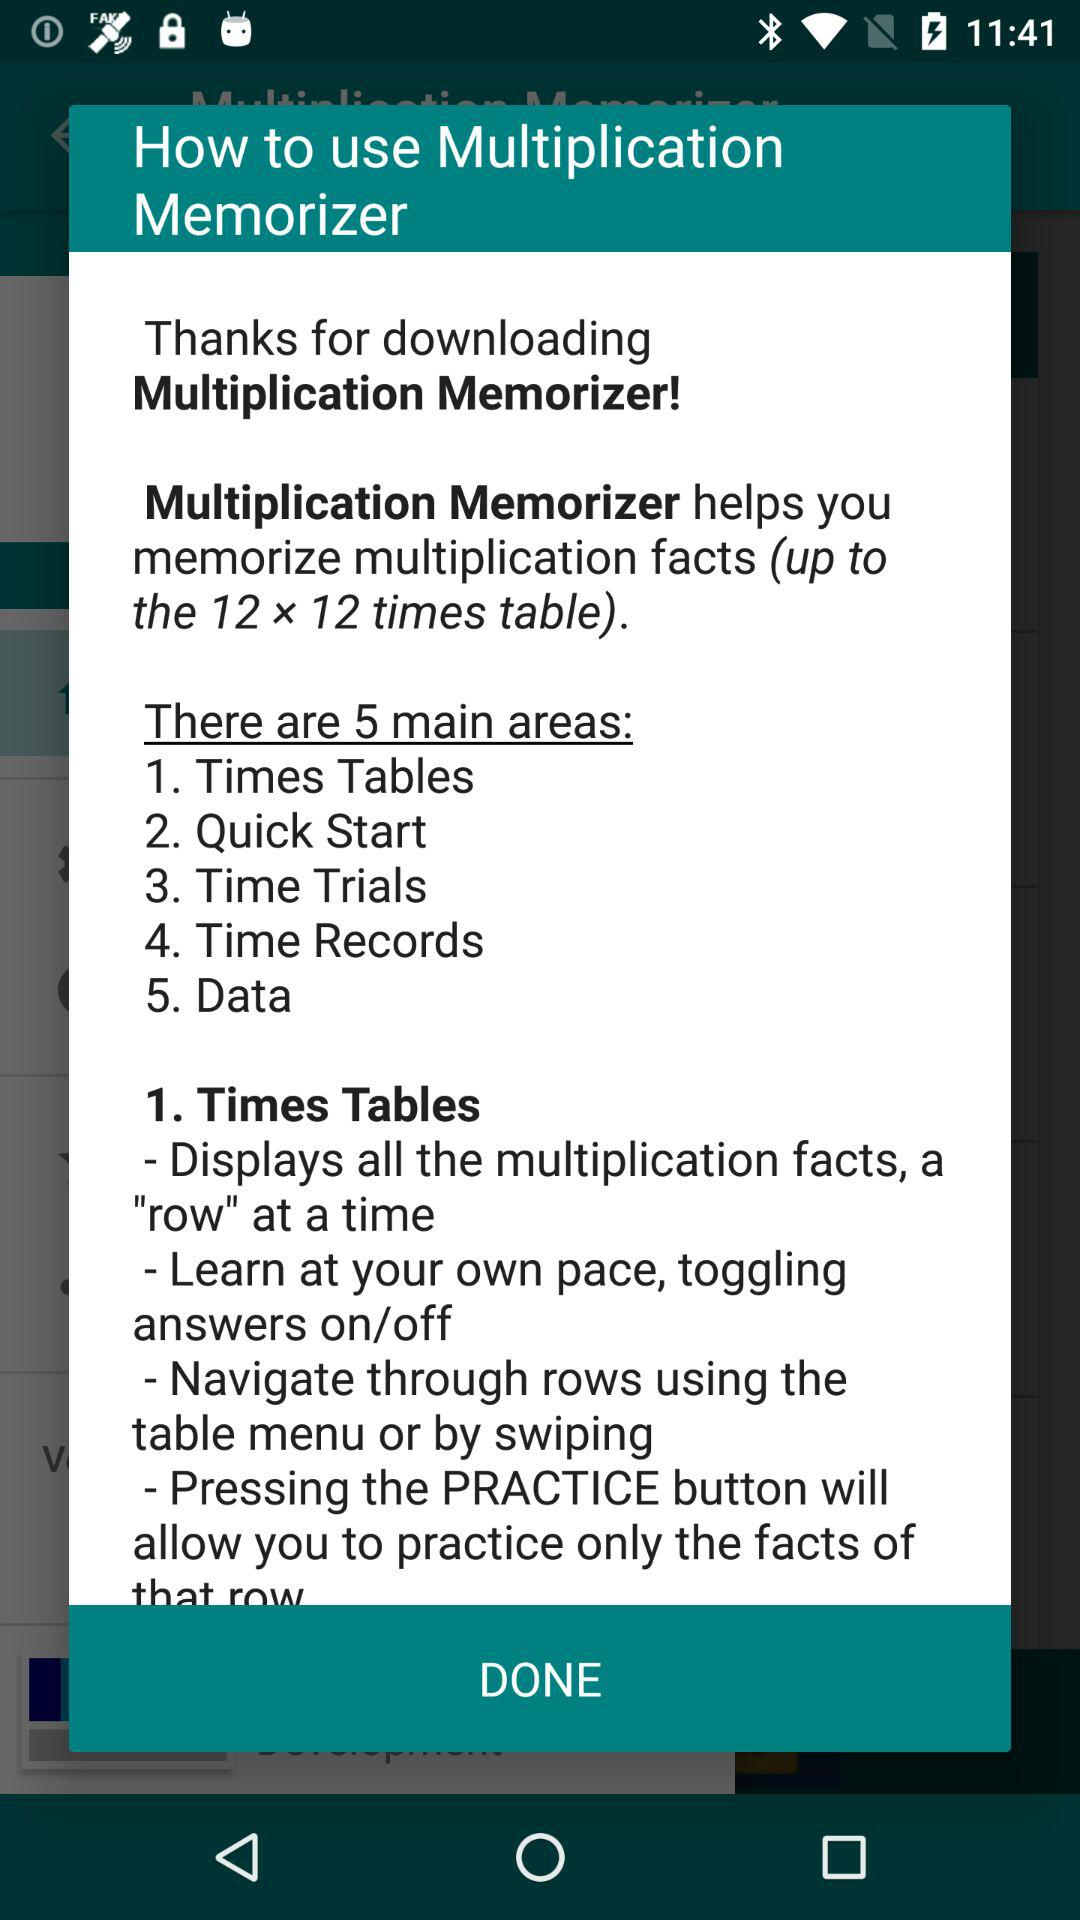What are the 5 main areas? The 5 main areas are "Times Tables", "Quick Start", "Time Trials", "Time Records" and "Data". 